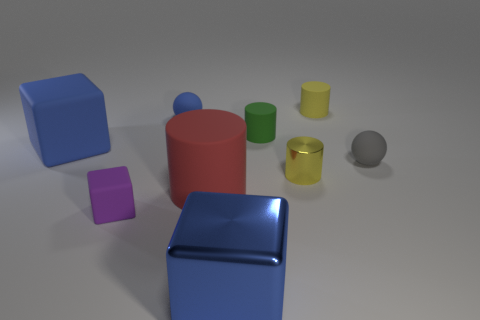The matte cylinder that is the same color as the tiny shiny thing is what size?
Ensure brevity in your answer.  Small. What number of other objects are there of the same size as the purple matte cube?
Your answer should be compact. 5. Is the green cylinder made of the same material as the large cube that is behind the big metallic block?
Your answer should be very brief. Yes. What number of objects are blue things that are on the right side of the large matte block or big green shiny spheres?
Your answer should be compact. 2. Are there any things that have the same color as the metal block?
Offer a very short reply. Yes. Is the shape of the small purple thing the same as the large blue thing that is behind the metal cylinder?
Your answer should be compact. Yes. How many tiny rubber spheres are on the right side of the big blue metallic block and to the left of the red thing?
Your response must be concise. 0. What is the material of the purple object that is the same shape as the blue metallic thing?
Offer a very short reply. Rubber. There is a yellow object that is behind the large object on the left side of the large rubber cylinder; what is its size?
Your response must be concise. Small. Are there any tiny balls?
Keep it short and to the point. Yes. 